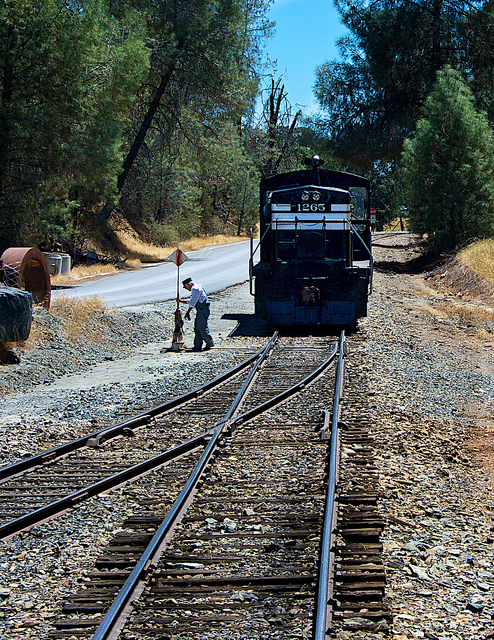How many people are visible? 1 